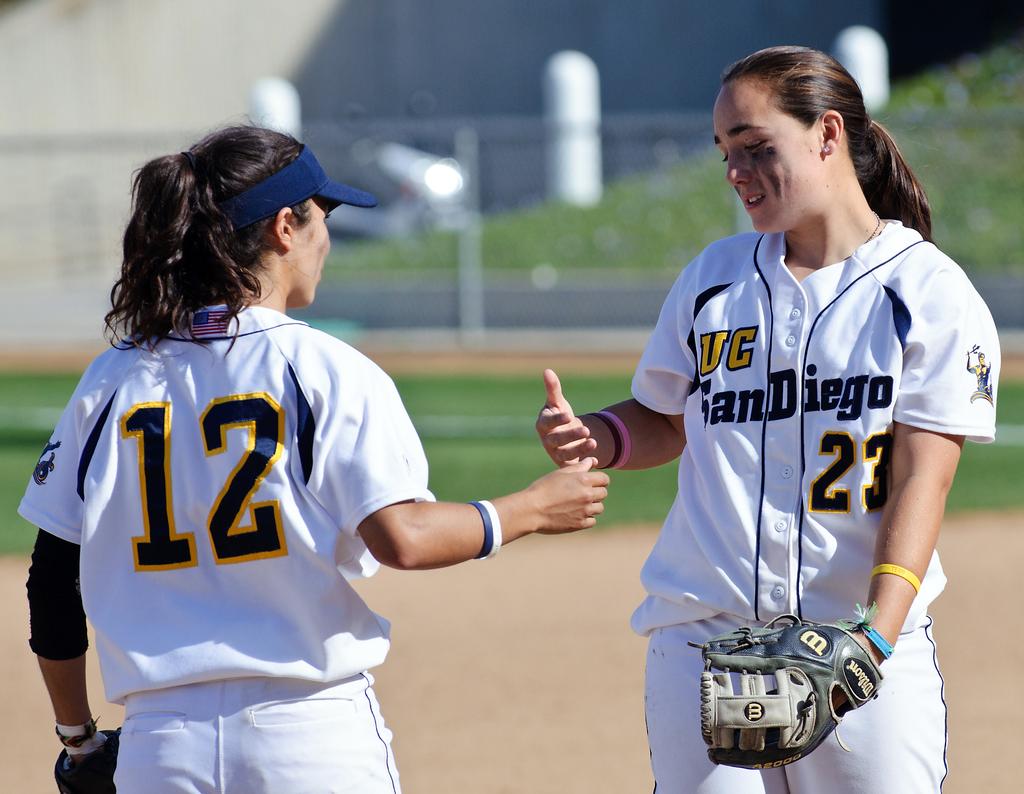What shirt number is printed on the back of the player on the left?
Offer a very short reply. 12. What is the player number of the girl on the right?
Provide a succinct answer. 23. 